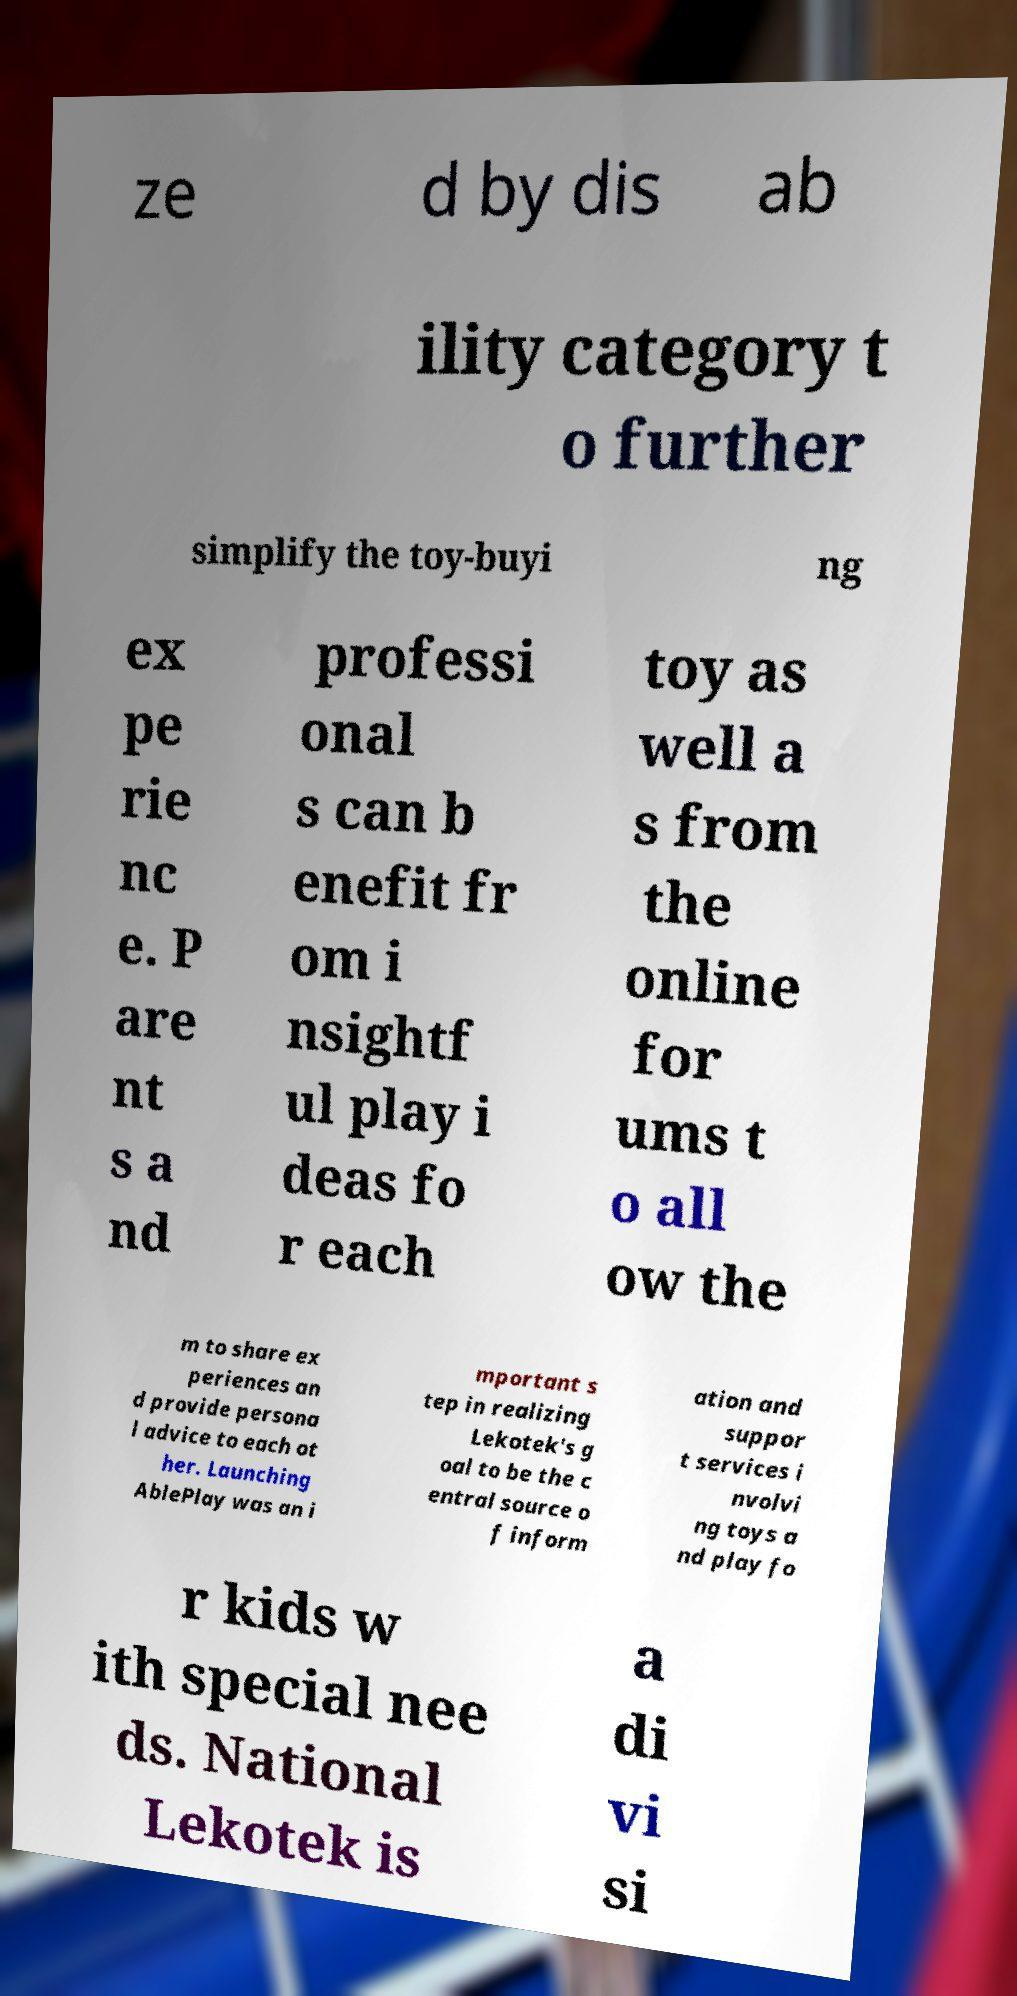Could you assist in decoding the text presented in this image and type it out clearly? ze d by dis ab ility category t o further simplify the toy-buyi ng ex pe rie nc e. P are nt s a nd professi onal s can b enefit fr om i nsightf ul play i deas fo r each toy as well a s from the online for ums t o all ow the m to share ex periences an d provide persona l advice to each ot her. Launching AblePlay was an i mportant s tep in realizing Lekotek's g oal to be the c entral source o f inform ation and suppor t services i nvolvi ng toys a nd play fo r kids w ith special nee ds. National Lekotek is a di vi si 